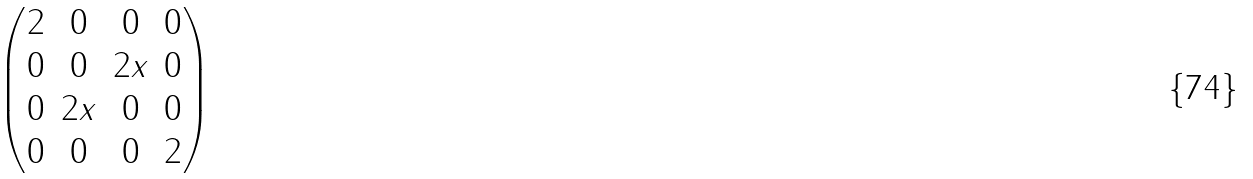Convert formula to latex. <formula><loc_0><loc_0><loc_500><loc_500>\begin{pmatrix} 2 & 0 & 0 & 0 \\ 0 & 0 & 2 x & 0 \\ 0 & 2 x & 0 & 0 \\ 0 & 0 & 0 & 2 \end{pmatrix}</formula> 